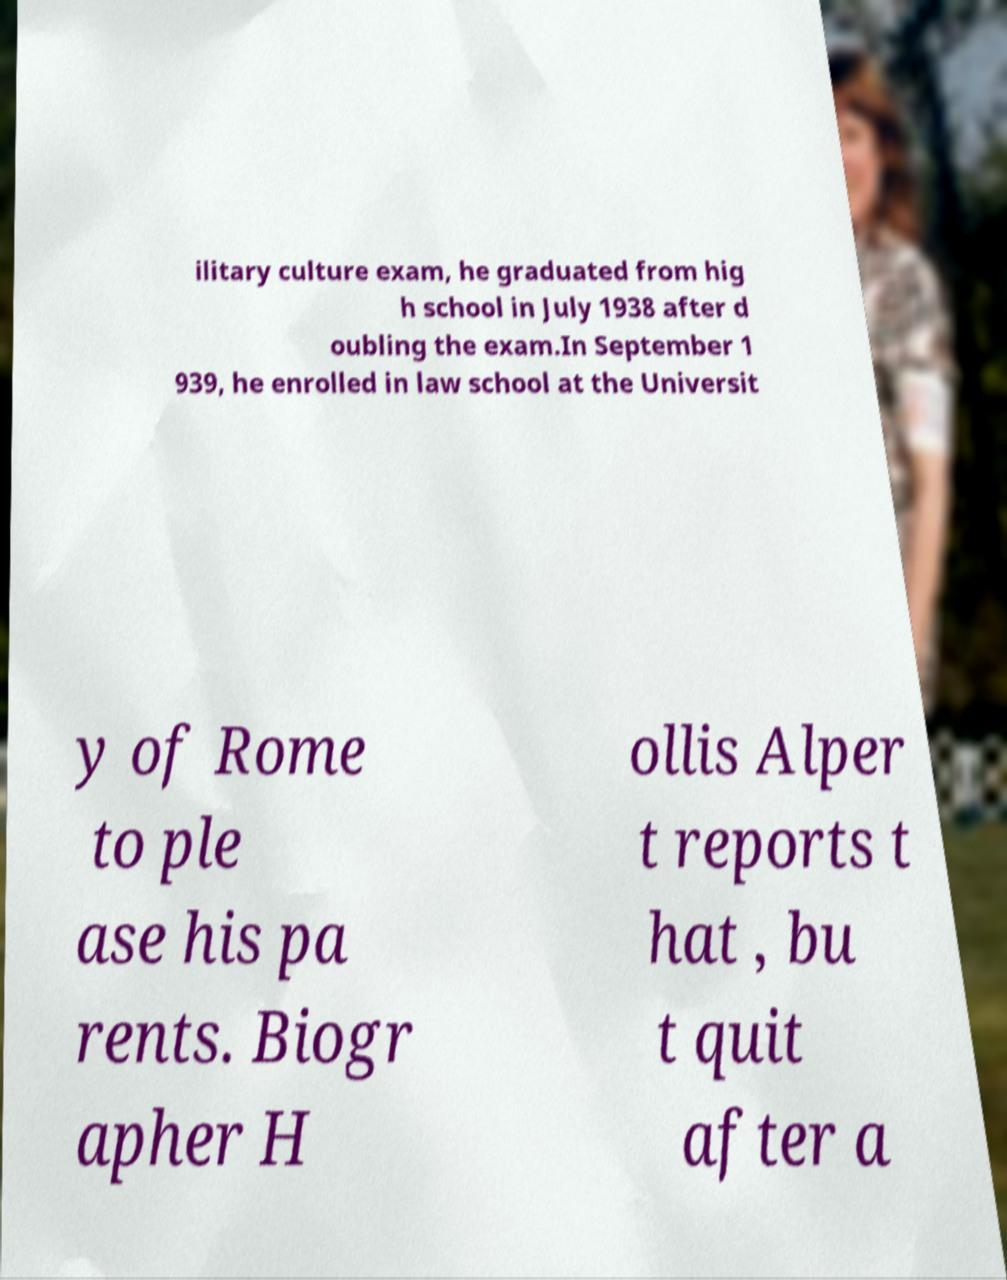Could you extract and type out the text from this image? ilitary culture exam, he graduated from hig h school in July 1938 after d oubling the exam.In September 1 939, he enrolled in law school at the Universit y of Rome to ple ase his pa rents. Biogr apher H ollis Alper t reports t hat , bu t quit after a 